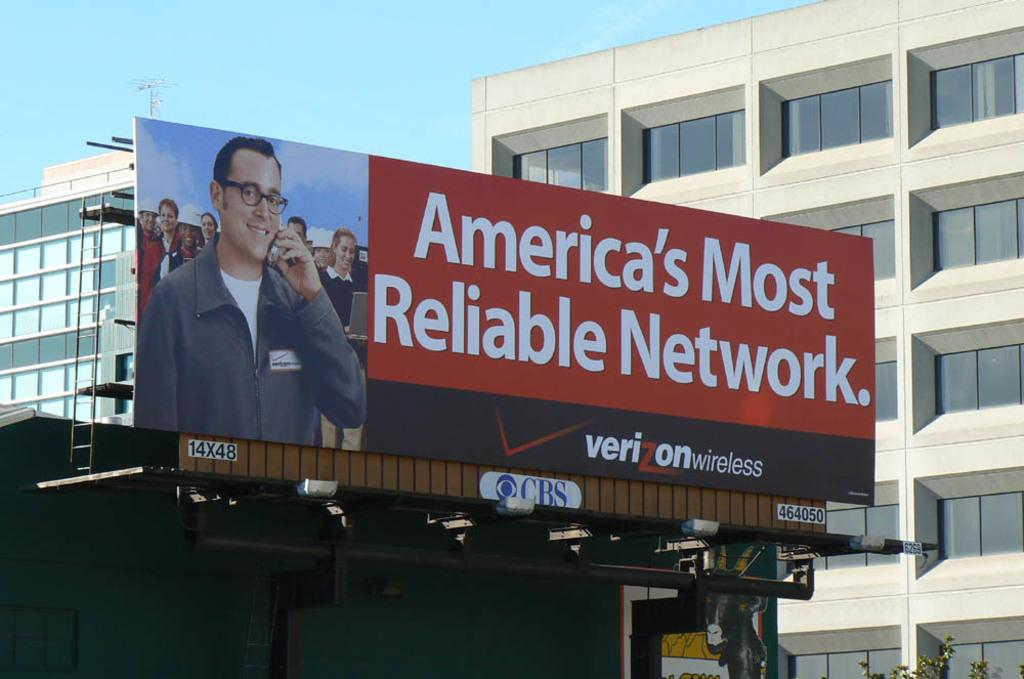Provide a one-sentence caption for the provided image. A billboard for Verizon states it's the most reliable network in America. 